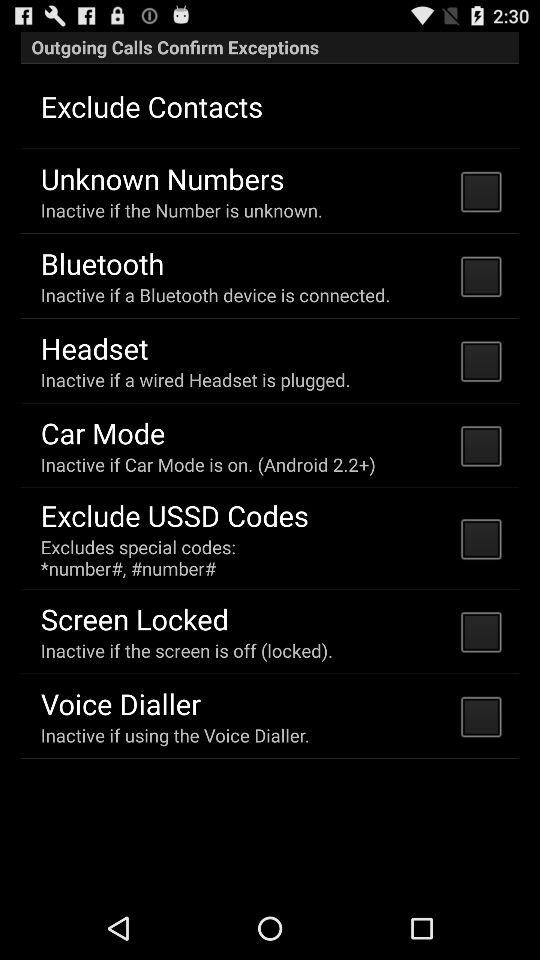Is "Car Mode" checked or not? "Car Mode" is unchecked. 